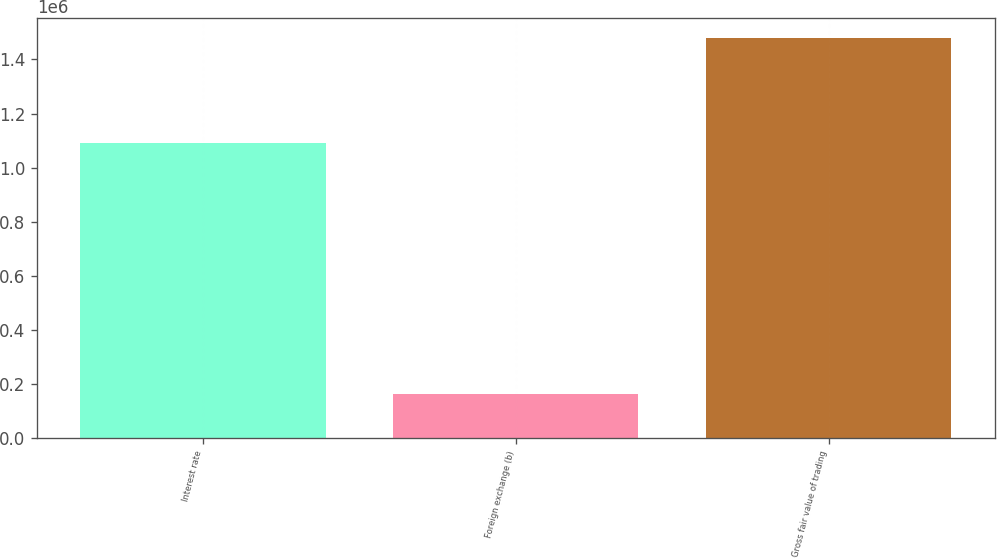Convert chart to OTSL. <chart><loc_0><loc_0><loc_500><loc_500><bar_chart><fcel>Interest rate<fcel>Foreign exchange (b)<fcel>Gross fair value of trading<nl><fcel>1.0896e+06<fcel>163671<fcel>1.48113e+06<nl></chart> 